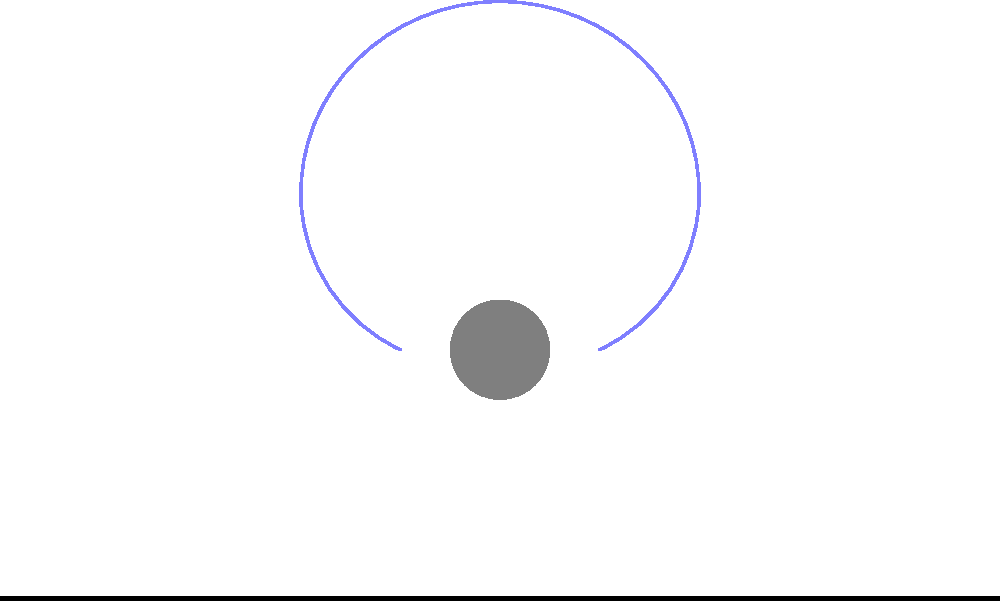In the diagram illustrating tear gas dispersion in a crowded area, what primary factor influences the asymmetrical spread of the gas, and how might this affect your photographic documentation of the event? To answer this question, let's analyze the biomechanics of tear gas dispersion step-by-step:

1. Initial release: The tear gas is released from a canister, typically at a height above the ground.

2. Dispersion pattern: The gas spreads in an asymmetrical pattern, as shown by the blue shaded area in the diagram.

3. Factors influencing dispersion:
   a. Wind direction and speed: The primary factor causing asymmetry in the dispersion pattern.
   b. Temperature and humidity: Affect the gas's density and how it moves through the air.
   c. Obstacles: Buildings, vehicles, or large groups of people can alter the gas flow.

4. Wind influence: The diagram shows the gas spreading more to one side, indicating wind direction from right to left.

5. Crowd interaction: The red circles represent people in the area. Their movement can further influence the gas dispersion.

6. Photographic considerations:
   a. Position: The asymmetrical spread affects where you might safely position yourself to capture images.
   b. Timing: The dispersion pattern changes over time, influencing when to capture key moments.
   c. Protective gear: Understanding the dispersion helps in choosing appropriate protective equipment.

7. Documentation impact: The asymmetrical spread creates areas of varying gas concentration, potentially leading to different crowd reactions in different areas, which could be crucial for your photographic narrative.
Answer: Wind direction 